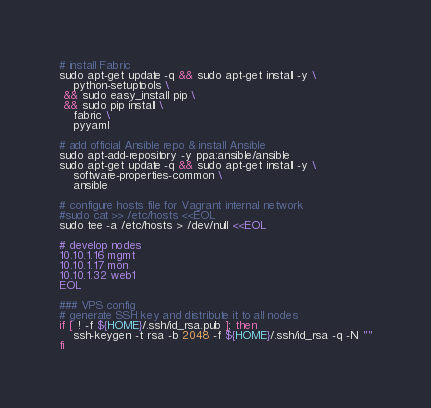Convert code to text. <code><loc_0><loc_0><loc_500><loc_500><_Bash_># install Fabric
sudo apt-get update -q && sudo apt-get install -y \
    python-setuptools \
 && sudo easy_install pip \
 && sudo pip install \
    fabric \
    pyyaml

# add official Ansible repo & install Ansible
sudo apt-add-repository -y ppa:ansible/ansible
sudo apt-get update -q && sudo apt-get install -y \
    software-properties-common \
    ansible

# configure hosts file for Vagrant internal network
#sudo cat >> /etc/hosts <<EOL
sudo tee -a /etc/hosts > /dev/null <<EOL

# develop nodes
10.10.1.16 mgmt
10.10.1.17 mon
10.10.1.32 web1
EOL

### VPS config
# generate SSH key and distribute it to all nodes
if [ ! -f ${HOME}/.ssh/id_rsa.pub ]; then
    ssh-keygen -t rsa -b 2048 -f ${HOME}/.ssh/id_rsa -q -N ""
fi

</code> 